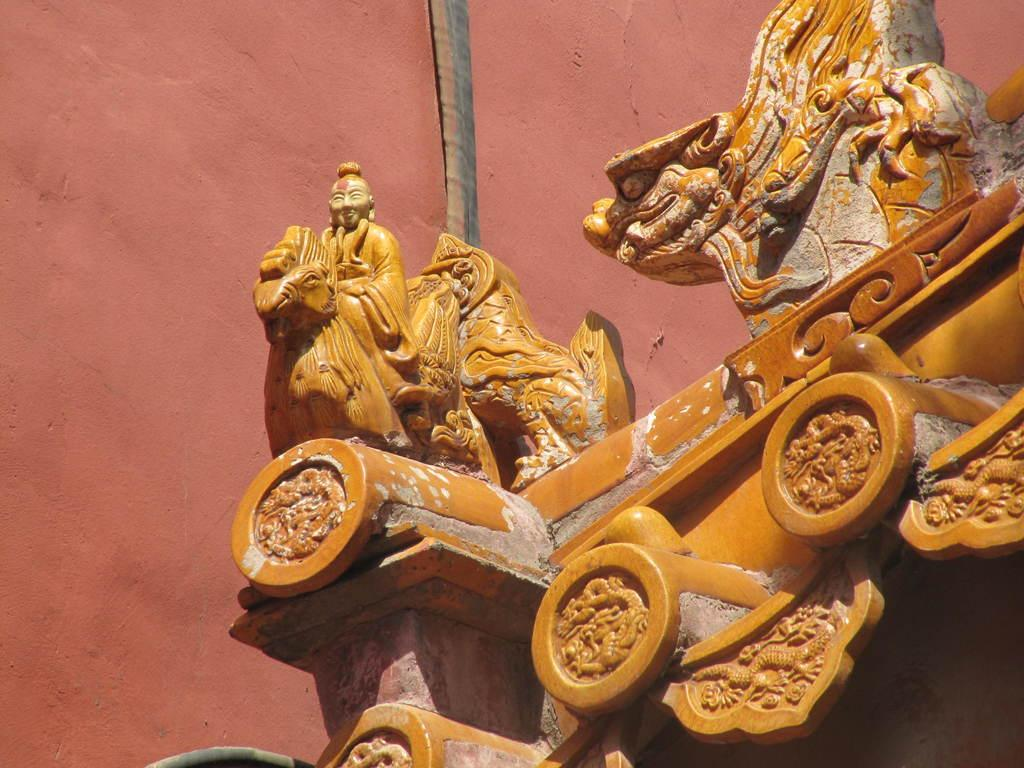What is the main structure in the image? There is a building in the image. What decorative elements are present on the building? There are sculptures on the building. What is located behind the sculptures? There is a wall behind the sculptures. What is the queen doing in the image? There is no queen present in the image. How many feet are visible in the image? There is no mention of feet or any body parts in the image. 